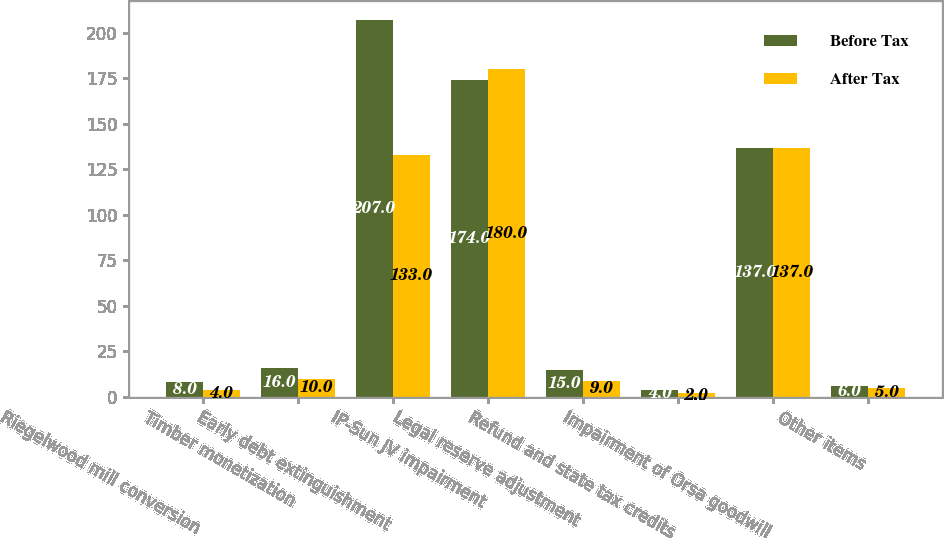Convert chart to OTSL. <chart><loc_0><loc_0><loc_500><loc_500><stacked_bar_chart><ecel><fcel>Riegelwood mill conversion<fcel>Timber monetization<fcel>Early debt extinguishment<fcel>IP-Sun JV impairment<fcel>Legal reserve adjustment<fcel>Refund and state tax credits<fcel>Impairment of Orsa goodwill<fcel>Other items<nl><fcel>Before Tax<fcel>8<fcel>16<fcel>207<fcel>174<fcel>15<fcel>4<fcel>137<fcel>6<nl><fcel>After Tax<fcel>4<fcel>10<fcel>133<fcel>180<fcel>9<fcel>2<fcel>137<fcel>5<nl></chart> 